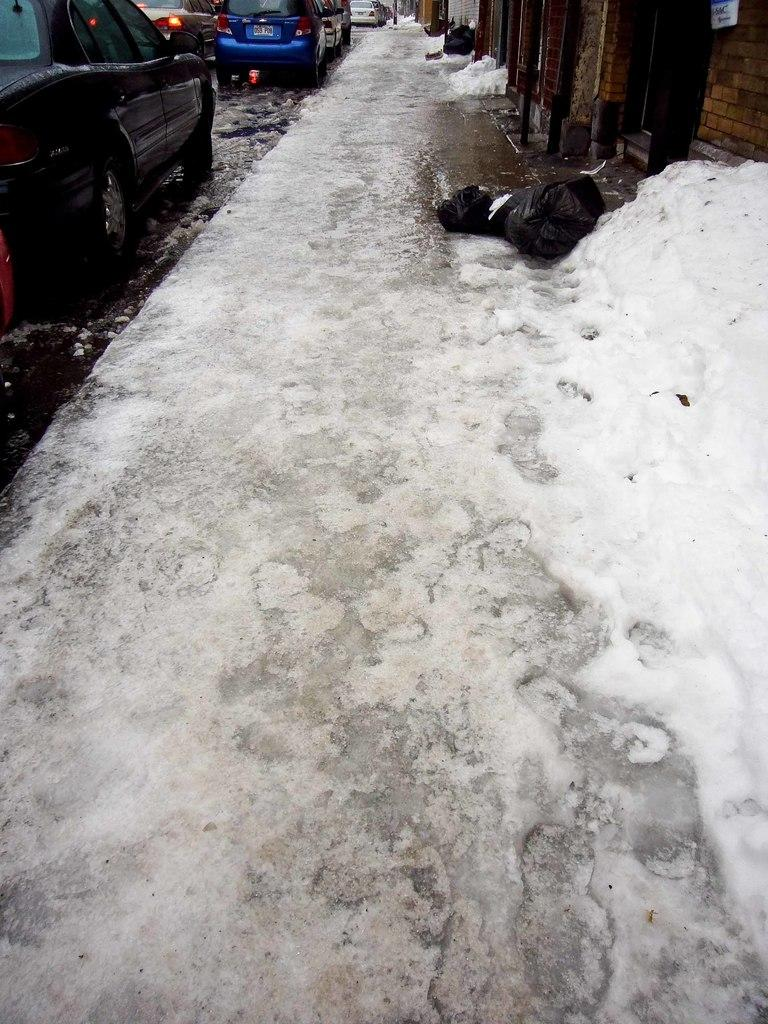What is the weather condition in the image? There is snow in the image, indicating a cold and wintry condition. What can be seen on the footpath in the image? There are objects on the footpath, which could be various items or obstacles. Where are the cars located in the image? The cars are in the top left of the image. What is present in the top right of the image? There is a wall in the top right of the image. Can you see a basketball being blown by the current in the image? There is no basketball or current present in the image. 